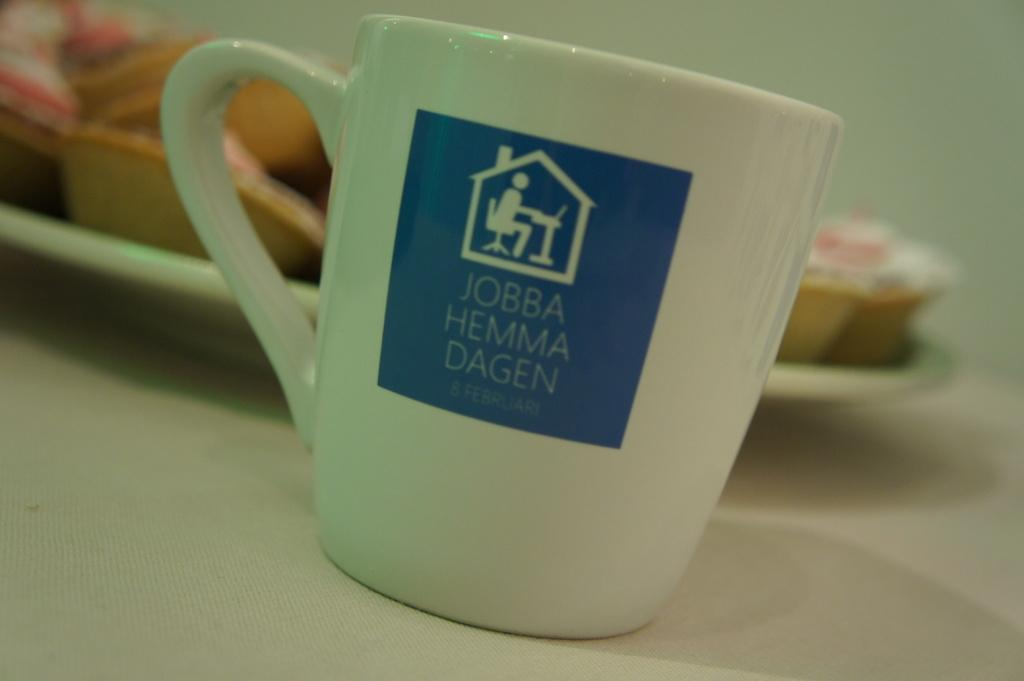What is present in the image that can hold liquids? There is a cup in the image that can hold liquids. Is there any text or design on the cup? Yes, the cup has something written on it. What is placed on the plate in the image? The plate has eatables placed on it. Where is the plate located in relation to the cup? The plate is beside the cup. What is the income of the person who owns the key in the image? There is no key present in the image, so it is not possible to determine the income of the person who might own a key. 